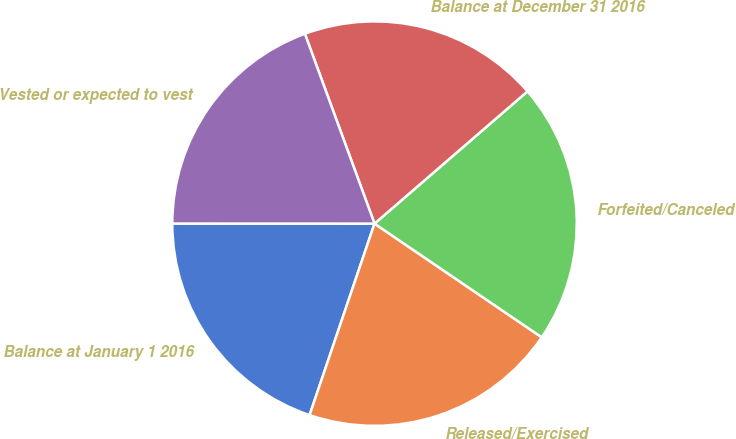<chart> <loc_0><loc_0><loc_500><loc_500><pie_chart><fcel>Balance at January 1 2016<fcel>Released/Exercised<fcel>Forfeited/Canceled<fcel>Balance at December 31 2016<fcel>Vested or expected to vest<nl><fcel>19.8%<fcel>20.7%<fcel>20.85%<fcel>19.25%<fcel>19.4%<nl></chart> 